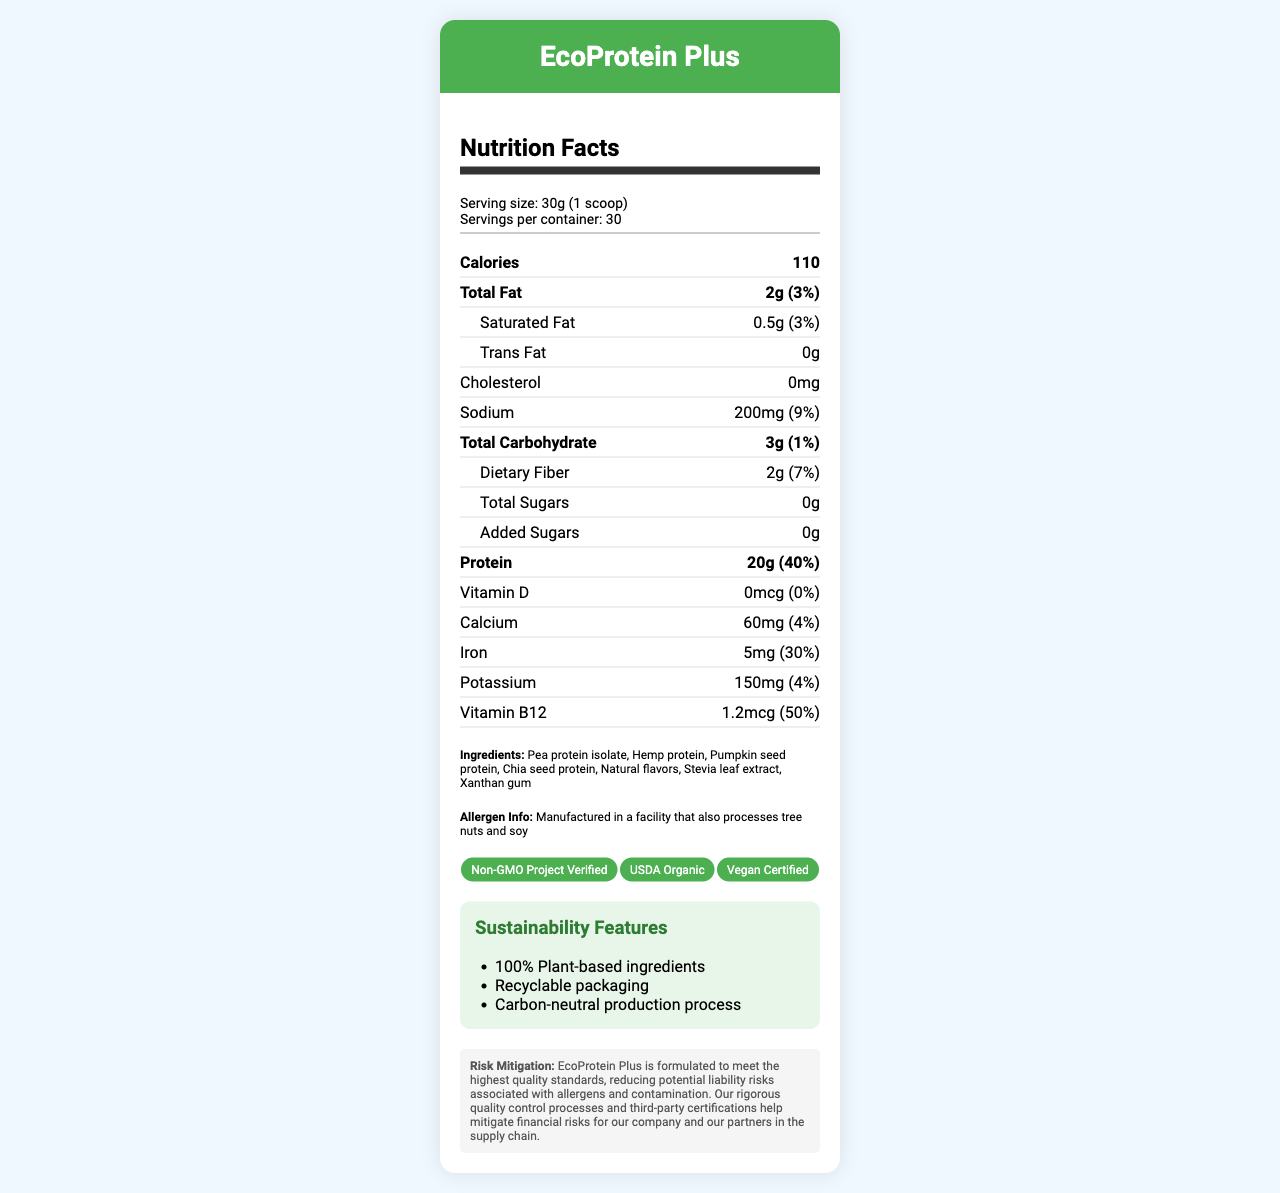what is the serving size? The serving size is specified under the serving information section of the document.
Answer: 30g (1 scoop) how many calories are in one serving of EcoProtein Plus? The number of calories is listed in the bold nutrient row near the top of the nutrition facts section.
Answer: 110 what is the total amount of dietary fiber per serving? It is located in the sub-nutrient row under the "Total Carbohydrate" section.
Answer: 2g does EcoProtein Plus contain any cholesterol? The document states "Cholesterol: 0mg" in the nutrition facts section.
Answer: No how much vitamin B12 is in each serving? The amount of vitamin B12 and its daily value percentage are listed in the nutrition facts section.
Answer: 1.2mcg which of the following certifications does EcoProtein Plus have? A. Gluten-Free B. USDA Organic C. Fair Trade Certified The certification badges in the document include "USDA Organic" but do not mention "Gluten-Free" or "Fair Trade Certified".
Answer: B. USDA Organic which ingredient is not included in EcoProtein Plus? i. Pea protein ii. Whey protein iii. Chia seed protein The listed ingredients on the document include "Pea protein isolate" and "Chia seed protein" but not "Whey protein".
Answer: ii. Whey protein does EcoProtein Plus have any added sugars? The document clearly states "Added Sugars: 0g" in the sub-nutrient row under "Total Sugars".
Answer: No summarize the main idea of this document. The document offers comprehensive information on the nutritional content, ingredient details, and certifications of EcoProtein Plus, emphasizing its health and sustainability benefits.
Answer: This document provides the nutrition facts for EcoProtein Plus, a plant-based protein powder marketed as a sustainable and health-conscious option. It includes details on serving size, calorie count, nutrient amounts, ingredients, allergen information, certifications, and sustainability features, along with a statement on risk mitigation. how does the sodium content in one serving compare to its daily value percentage? The sodium content per serving is 200mg, which accounts for 9% of the daily value as indicated in the document.
Answer: 200mg (9%) what is the manufacturer’s risk mitigation strategy for EcoProtein Plus? The risk mitigation statement at the bottom of the document highlights quality control processes and third-party certifications that help mitigate financial risks.
Answer: EcoProtein Plus is formulated to meet the highest quality standards, reducing potential liability risks associated with allergens and contamination. is the product non-GMO certified? One of the certification badges in the document is "Non-GMO Project Verified".
Answer: Yes what is the vitamin D content in this product? The document indicates that the product contains 0mcg of Vitamin D.
Answer: 0mcg how many servings are there in one container of EcoProtein Plus? The serving information section specifies that there are 30 servings per container.
Answer: 30 what is the carbon footprint of producing this product? The document does not provide specific details on the carbon footprint, only mentioning that the production process is carbon-neutral.
Answer: Not enough information 